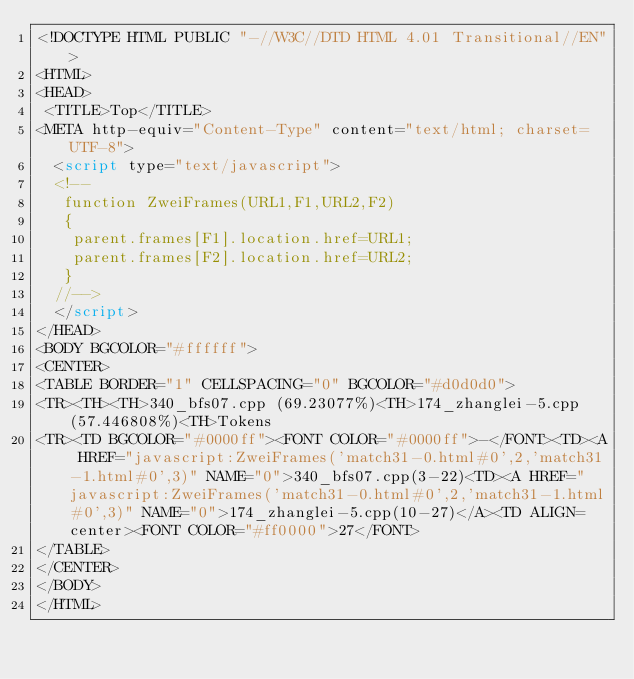<code> <loc_0><loc_0><loc_500><loc_500><_HTML_><!DOCTYPE HTML PUBLIC "-//W3C//DTD HTML 4.01 Transitional//EN">
<HTML>
<HEAD>
 <TITLE>Top</TITLE>
<META http-equiv="Content-Type" content="text/html; charset=UTF-8">
  <script type="text/javascript">
  <!--
   function ZweiFrames(URL1,F1,URL2,F2)
   {
    parent.frames[F1].location.href=URL1;
    parent.frames[F2].location.href=URL2;
   }
  //-->
  </script>
</HEAD>
<BODY BGCOLOR="#ffffff">
<CENTER>
<TABLE BORDER="1" CELLSPACING="0" BGCOLOR="#d0d0d0">
<TR><TH><TH>340_bfs07.cpp (69.23077%)<TH>174_zhanglei-5.cpp (57.446808%)<TH>Tokens
<TR><TD BGCOLOR="#0000ff"><FONT COLOR="#0000ff">-</FONT><TD><A HREF="javascript:ZweiFrames('match31-0.html#0',2,'match31-1.html#0',3)" NAME="0">340_bfs07.cpp(3-22)<TD><A HREF="javascript:ZweiFrames('match31-0.html#0',2,'match31-1.html#0',3)" NAME="0">174_zhanglei-5.cpp(10-27)</A><TD ALIGN=center><FONT COLOR="#ff0000">27</FONT>
</TABLE>
</CENTER>
</BODY>
</HTML>

</code> 